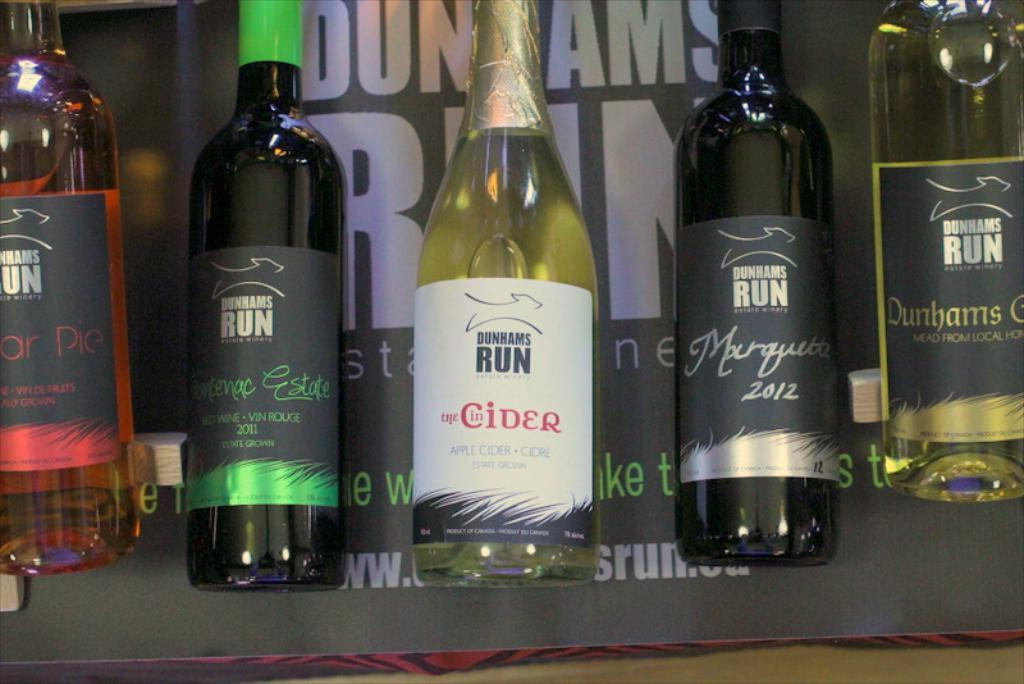<image>
Write a terse but informative summary of the picture. A selection of different types of wine and apple cider made by the company Dunhams Run. 